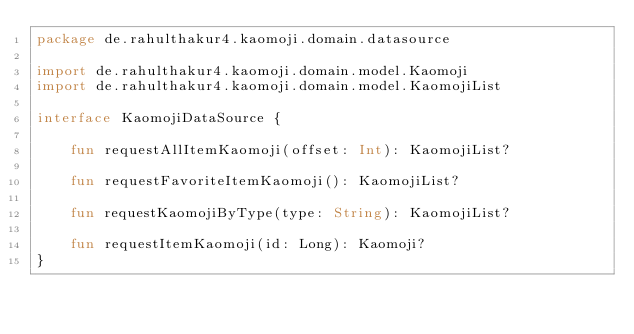<code> <loc_0><loc_0><loc_500><loc_500><_Kotlin_>package de.rahulthakur4.kaomoji.domain.datasource

import de.rahulthakur4.kaomoji.domain.model.Kaomoji
import de.rahulthakur4.kaomoji.domain.model.KaomojiList

interface KaomojiDataSource {

    fun requestAllItemKaomoji(offset: Int): KaomojiList?

    fun requestFavoriteItemKaomoji(): KaomojiList?

    fun requestKaomojiByType(type: String): KaomojiList?

    fun requestItemKaomoji(id: Long): Kaomoji?
}</code> 